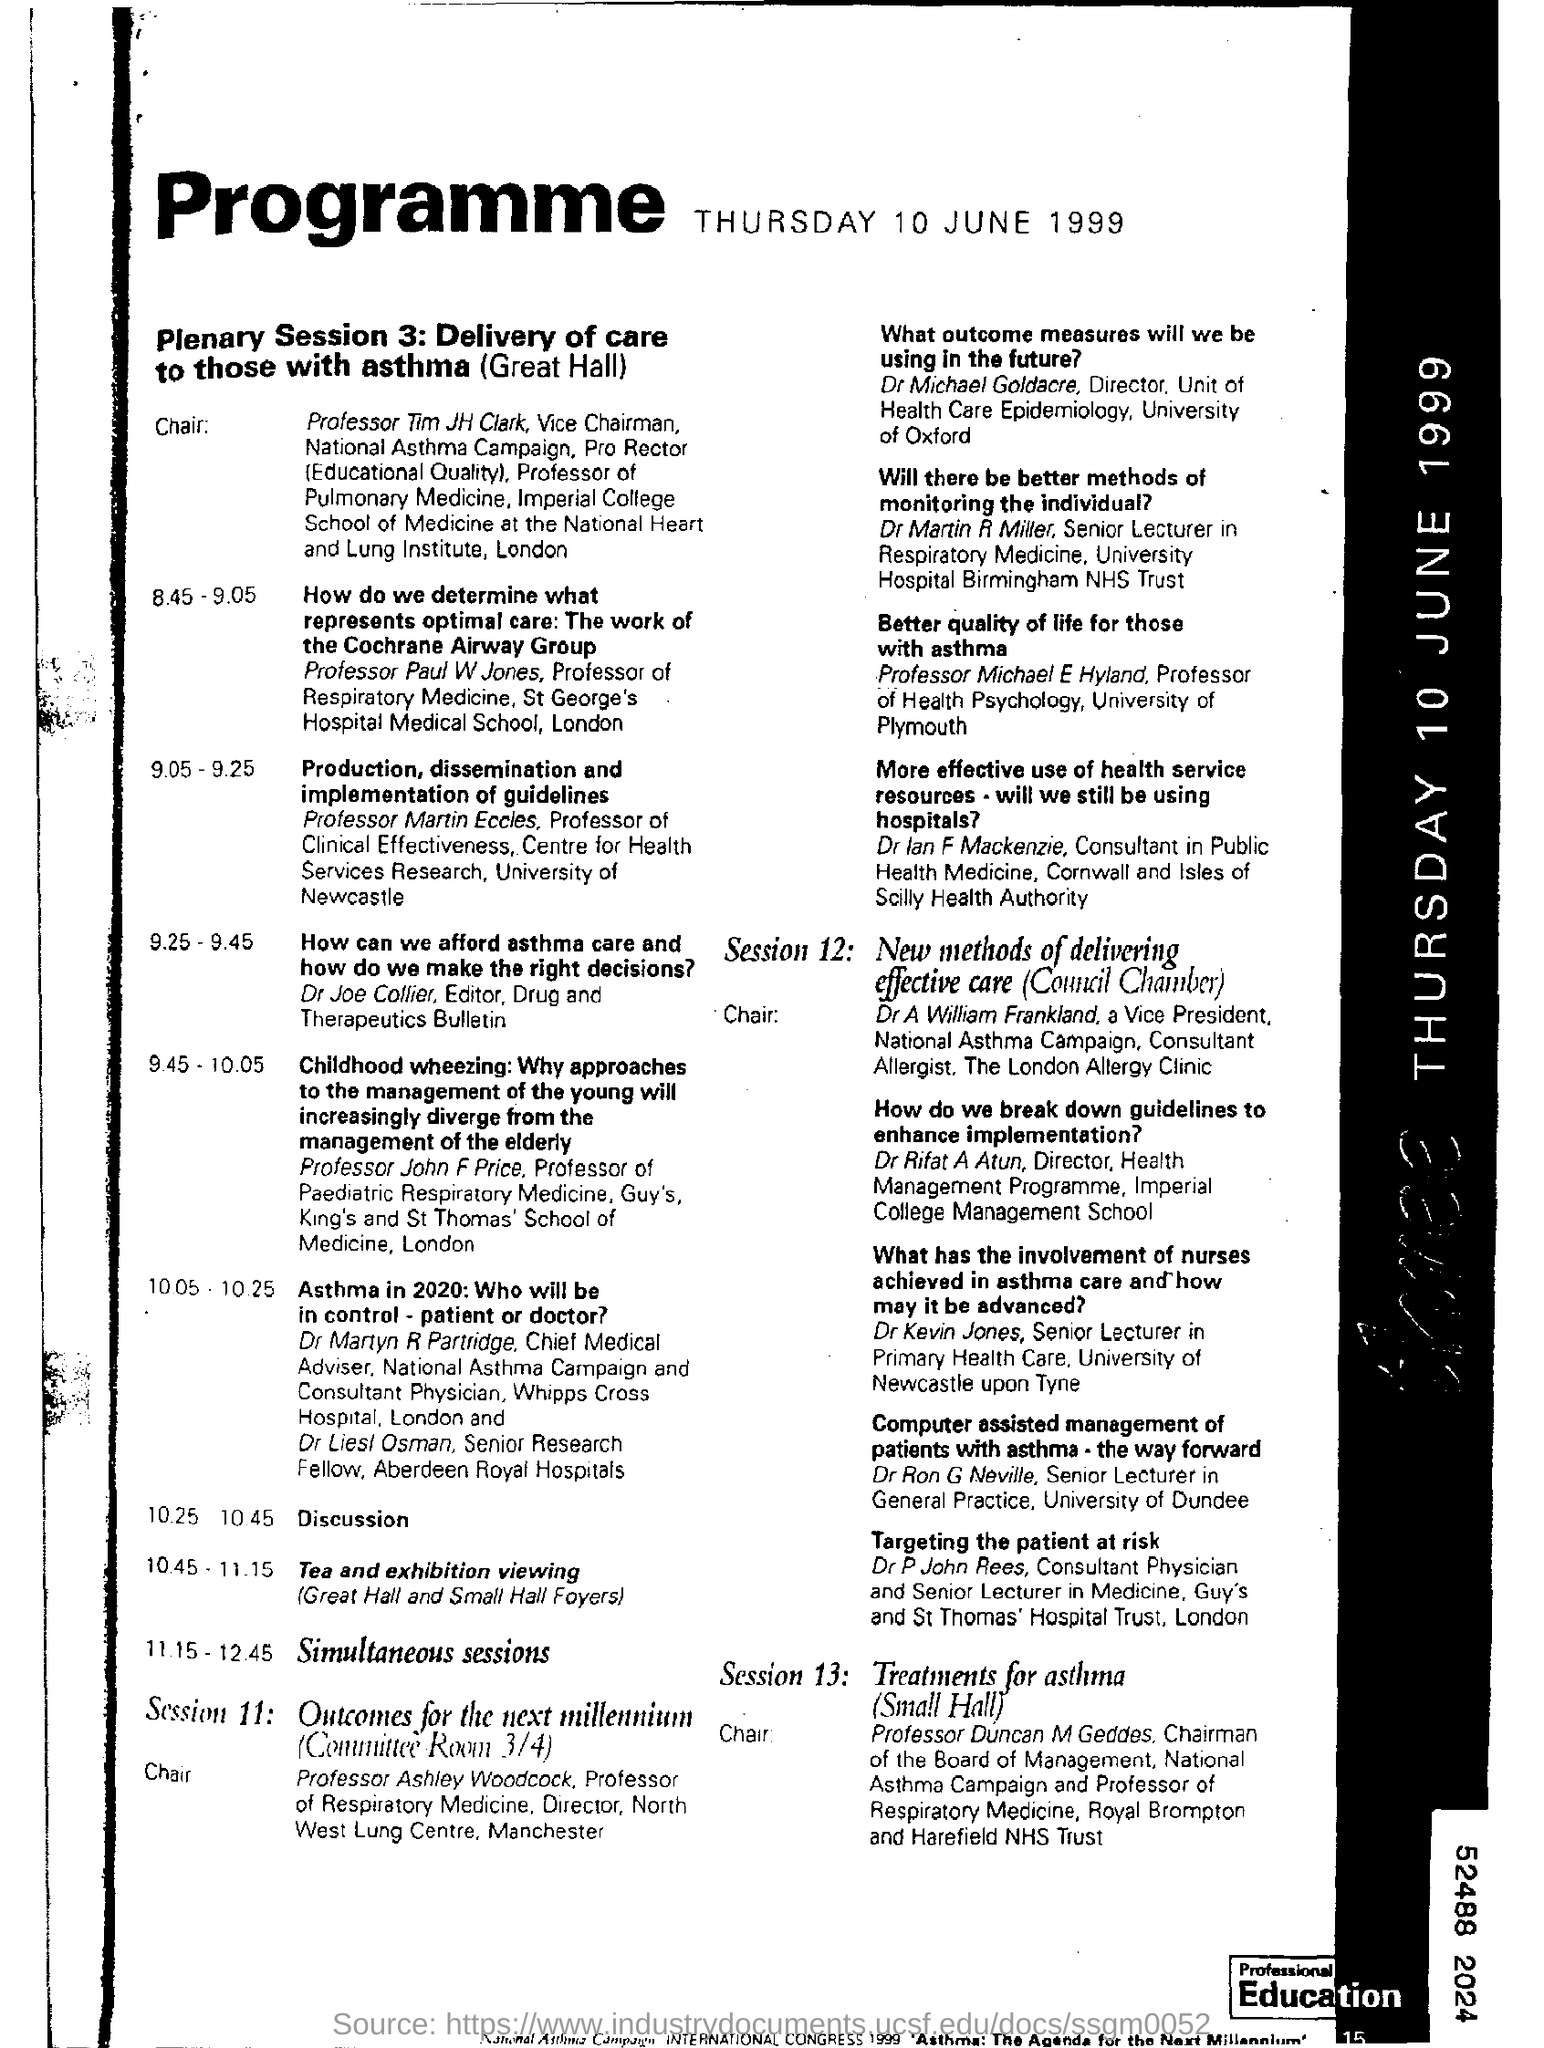What is the Plenary session 3 about?
Make the answer very short. Delivery of care to those with asthma. When is the programme going to be held?
Make the answer very short. THURSDAY 10 JUNE 1999. Where is the Session 11 going to be held?
Give a very brief answer. Committee Room 3/4. What is Session 12 about?
Offer a very short reply. New methods of delivering effective care. Who is Dr Joe Collier?
Your response must be concise. Editor, Drug and Therapeutics Bulletin. 